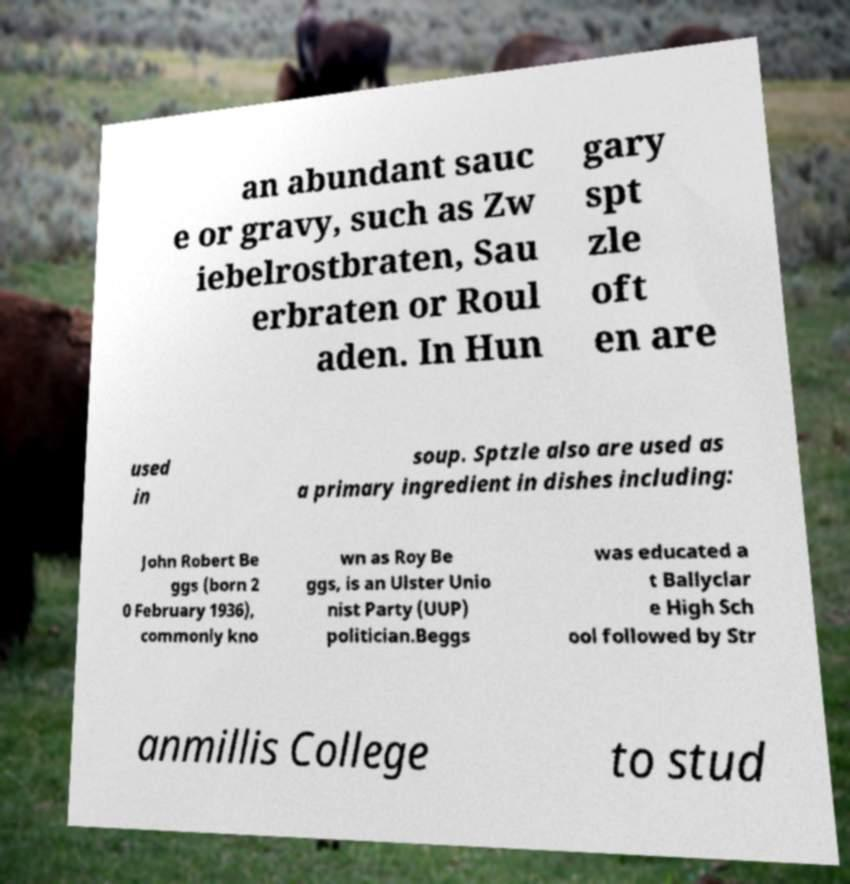What messages or text are displayed in this image? I need them in a readable, typed format. an abundant sauc e or gravy, such as Zw iebelrostbraten, Sau erbraten or Roul aden. In Hun gary spt zle oft en are used in soup. Sptzle also are used as a primary ingredient in dishes including: John Robert Be ggs (born 2 0 February 1936), commonly kno wn as Roy Be ggs, is an Ulster Unio nist Party (UUP) politician.Beggs was educated a t Ballyclar e High Sch ool followed by Str anmillis College to stud 